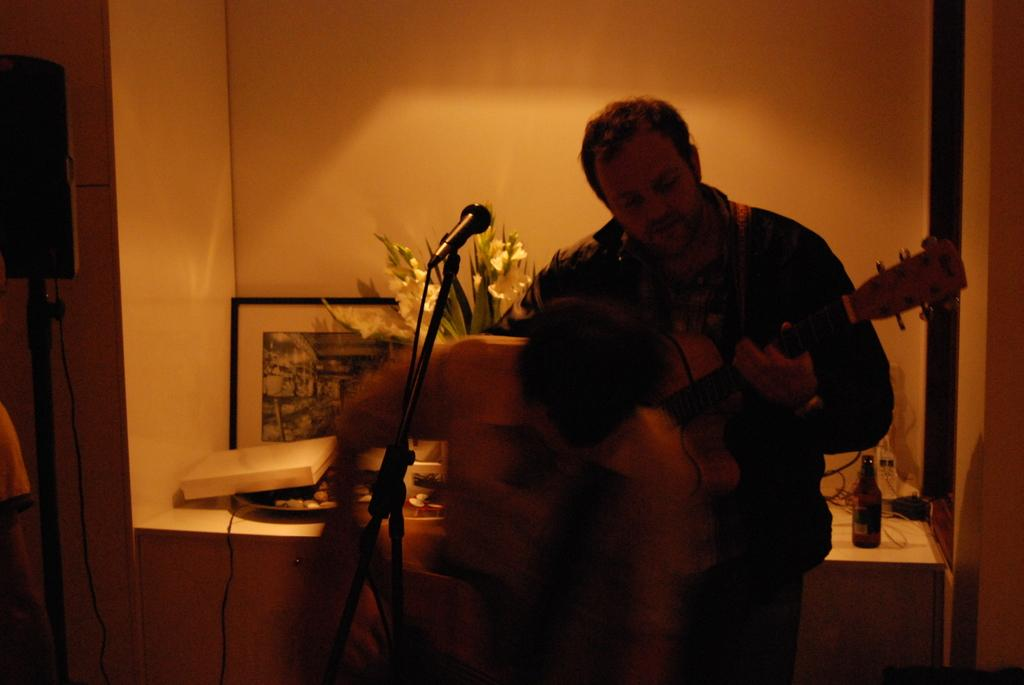What are the two men in the image doing? One man is standing and playing a guitar, while the other man is holding a guitar. What object is present in front of the two men? A microphone is present in front of the two men. What can be seen in the background of the image? There is a photo frame and a plant in the background of the image. What type of care is the cat receiving in the image? There is no cat present in the image, so no care can be observed. What season is depicted in the image? The image does not depict a specific season, as there are no seasonal cues present. 